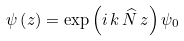<formula> <loc_0><loc_0><loc_500><loc_500>\psi \left ( z \right ) = \exp \left ( i \, k \, \widehat { N } \, z \right ) \psi _ { 0 }</formula> 